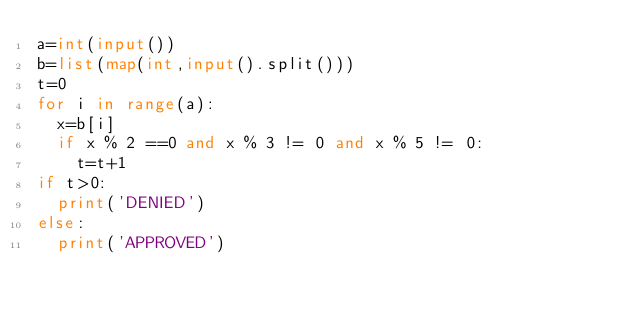Convert code to text. <code><loc_0><loc_0><loc_500><loc_500><_Python_>a=int(input())
b=list(map(int,input().split()))
t=0
for i in range(a):
	x=b[i]
	if x % 2 ==0 and x % 3 != 0 and x % 5 != 0:
		t=t+1
if t>0:
	print('DENIED')
else:
	print('APPROVED')</code> 